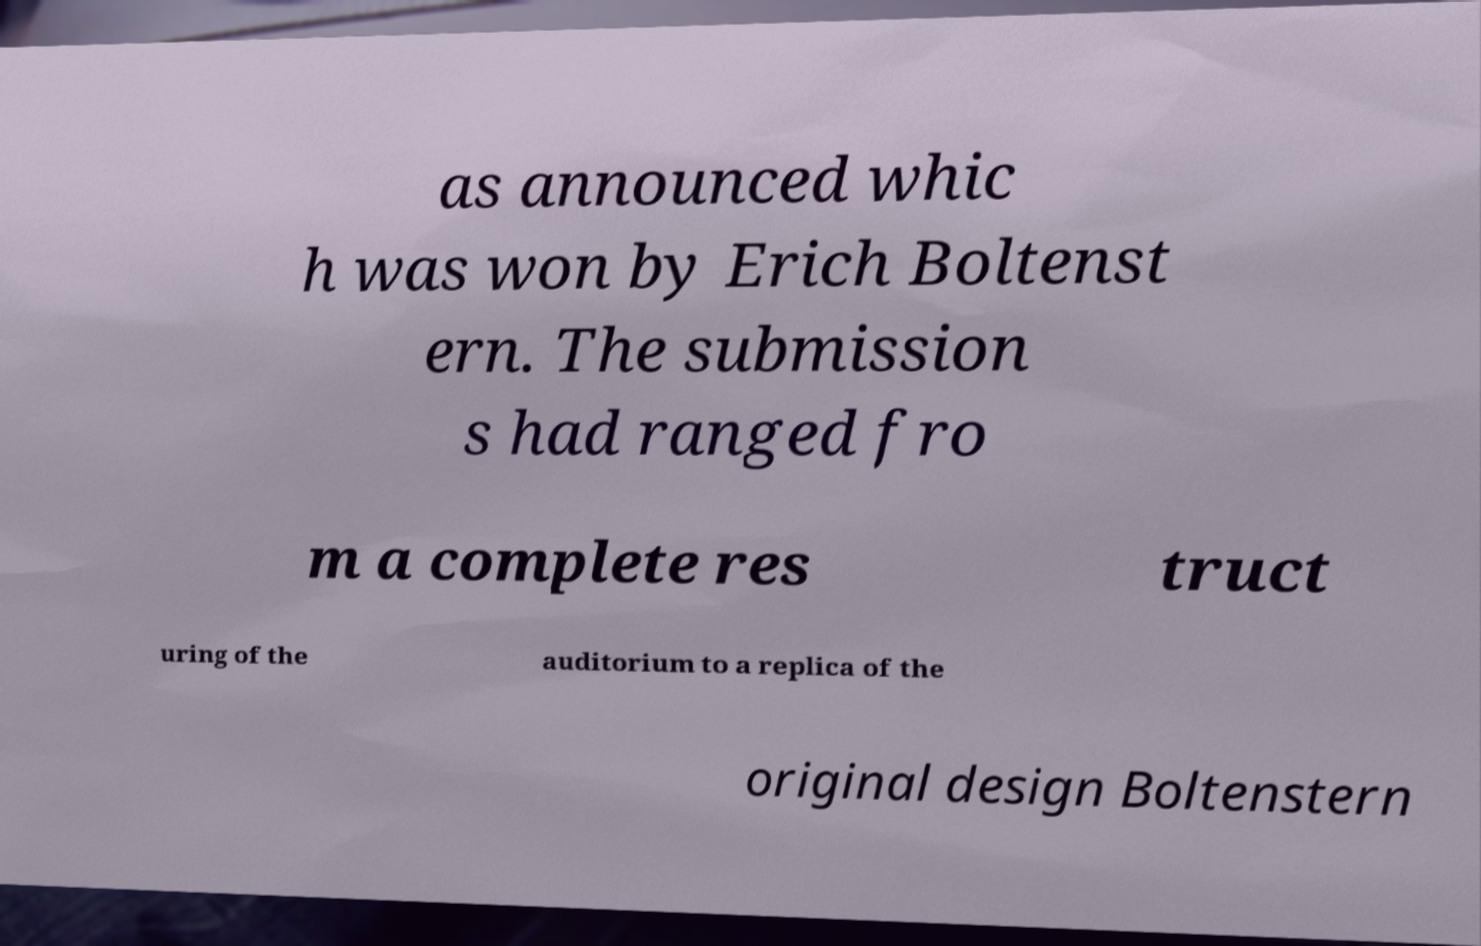There's text embedded in this image that I need extracted. Can you transcribe it verbatim? as announced whic h was won by Erich Boltenst ern. The submission s had ranged fro m a complete res truct uring of the auditorium to a replica of the original design Boltenstern 